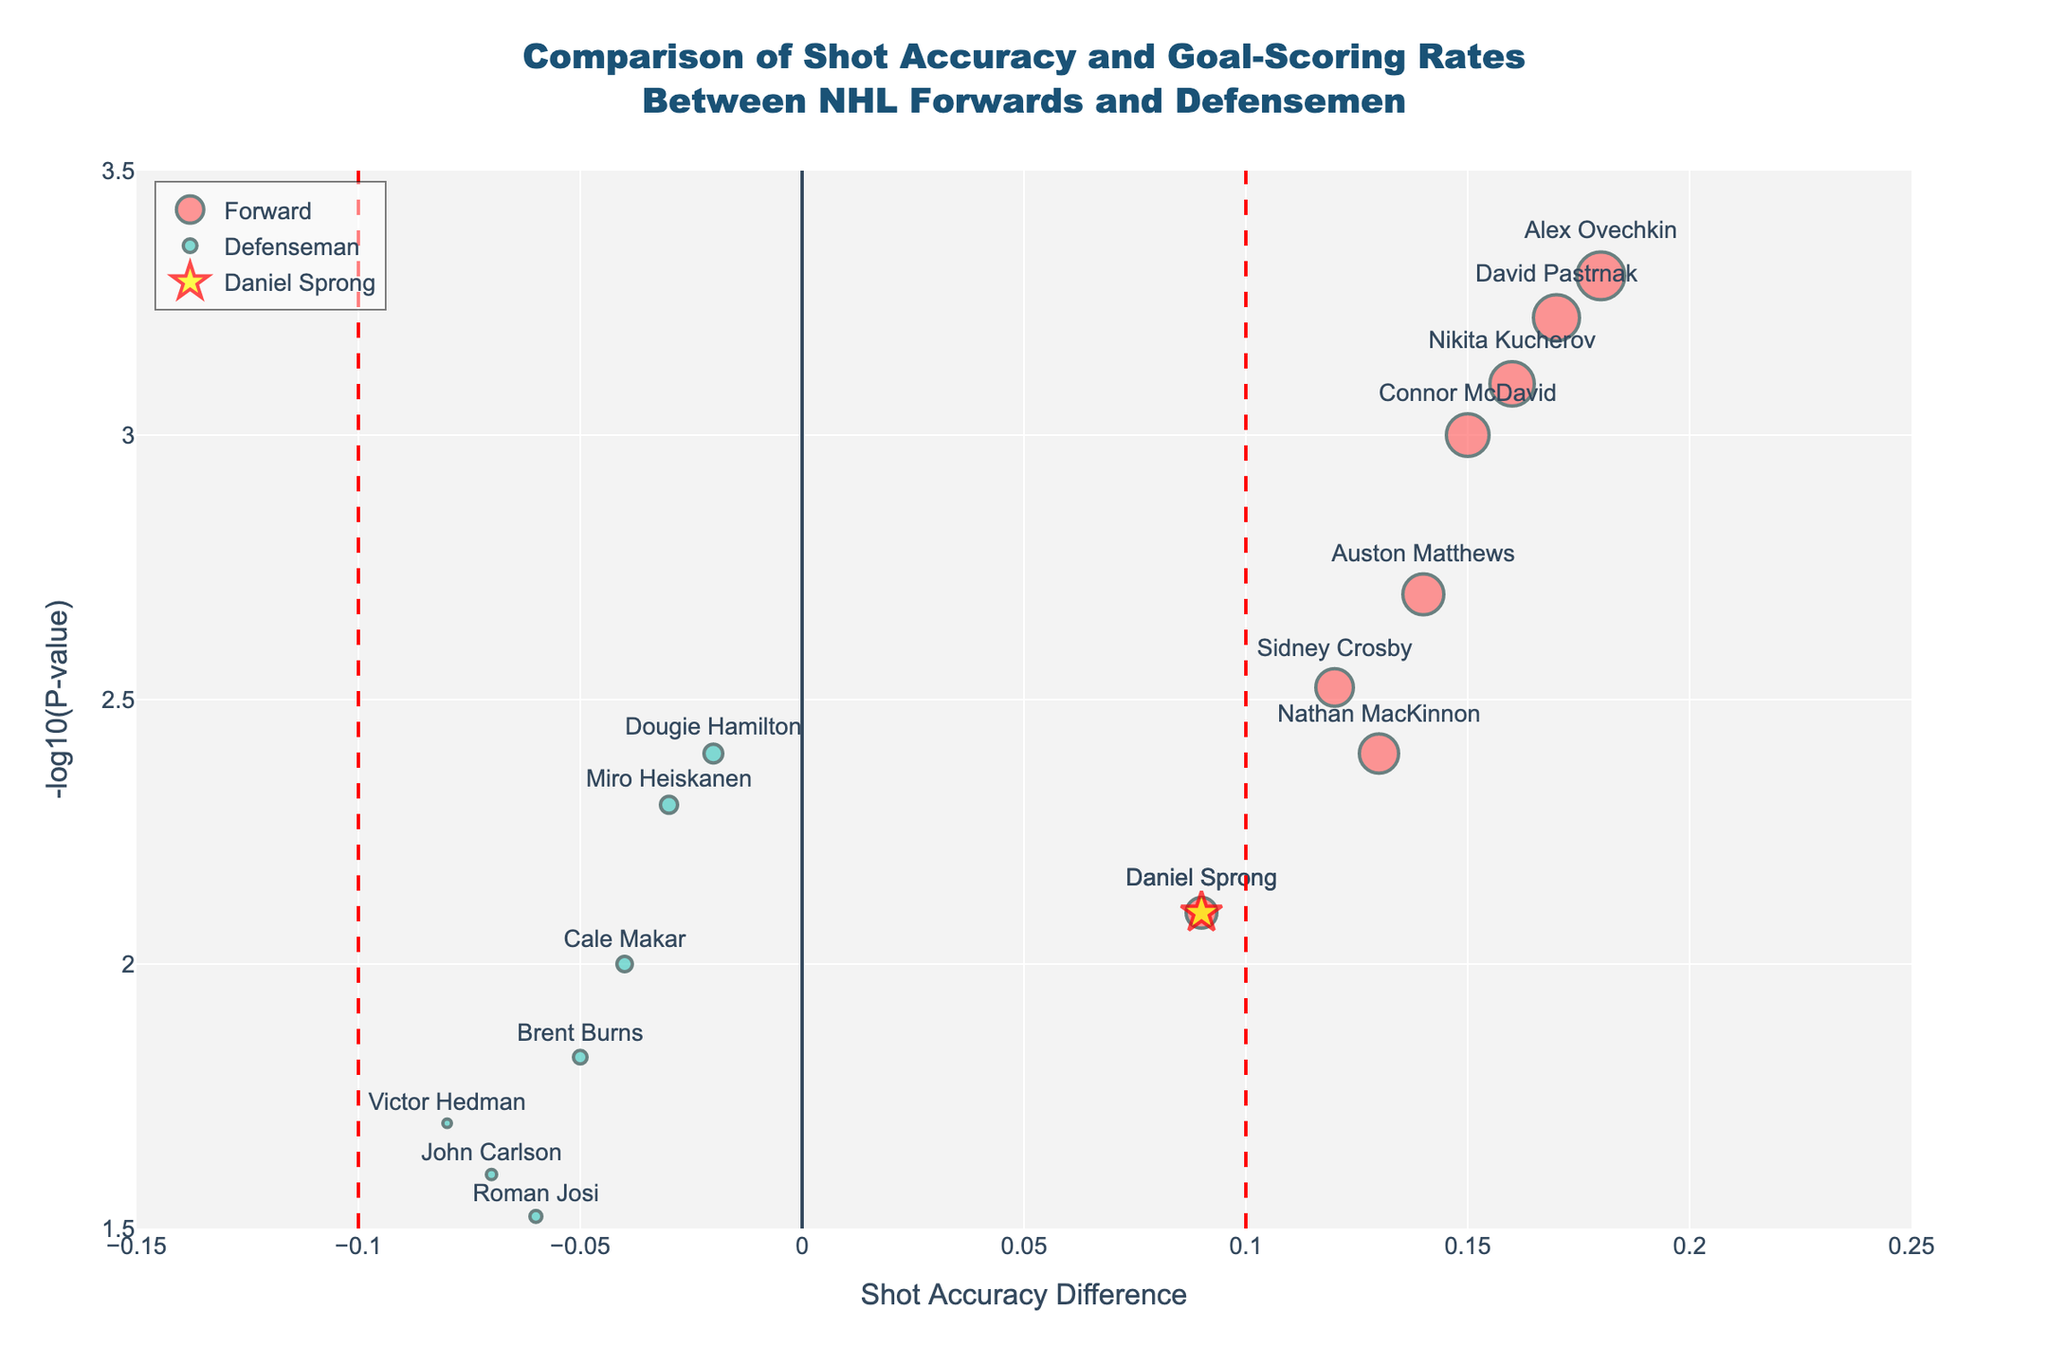What are the two key metrics compared in this plot? The plot compares shot accuracy difference and goal-scoring rate difference between NHL forwards and defensemen.
Answer: Shot accuracy difference and goal-scoring rate difference How many forwards and defensemen data points are shown in the plot? There are 9 forwards and 6 defensemen data points indicated by the colors and names in the plot.
Answer: 9 forwards and 6 defensemen Which player has the highest shot accuracy difference? By locating the data point with the highest value on the x-axis, Alex Ovechkin shows the highest shot accuracy difference of 0.18.
Answer: Alex Ovechkin What is highlighted by the vertical red lines? The vertical red lines at x = 0.1 and x = -0.1 highlight the threshold for significant shot accuracy differences.
Answer: Significance threshold What is the difference in goal-scoring rate difference between the player with the highest (Alex Ovechkin) and lowest (Victor Hedman) shot accuracy difference? Alex Ovechkin has the highest goal-scoring rate difference of 0.28, and Victor Hedman has the lowest of 0.05. The difference is 0.28 - 0.05 = 0.23.
Answer: 0.23 Among defensemen, who has the smallest P-value? By observing the y-axis (-log10(P-value)) for defensemen, Miro Heiskanen has the smallest P-value, with the highest y-value among them.
Answer: Miro Heiskanen How does Daniel Sprong’s performance stand out in this plot? Daniel Sprong is highlighted in yellow with a star symbol. His shot accuracy and goal-scoring rate differences are also significant, indicated by higher marker size.
Answer: Highlighted in yellow with a star Which player has the highest y-value and what does it signify? The highest y-value belongs to Alex Ovechkin, which signifies the lowest P-value (highest statistical significance).
Answer: Alex Ovechkin Compare the average shot accuracy difference between forwards and defensemen. The average shot accuracy difference for forwards is approximately 0.14, while for defensemen, it's approximately -0.05. Calculated by summing their individual values and dividing by the number of players in each group.
Answer: Forwards: ~0.14, Defensemen: ~-0.05 What does a negative shot accuracy difference indicate? A negative shot accuracy difference means the player's shot accuracy is lower compared to the average of their comparison group.
Answer: Lower shot accuracy 